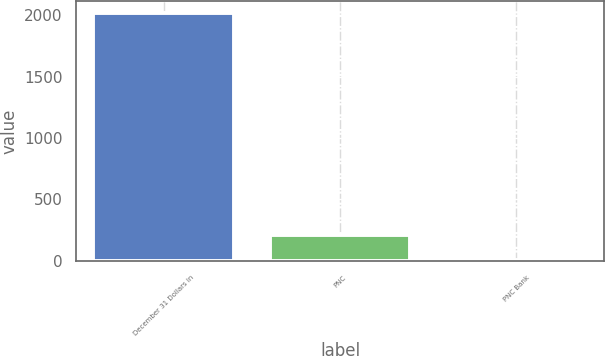Convert chart to OTSL. <chart><loc_0><loc_0><loc_500><loc_500><bar_chart><fcel>December 31 Dollars in<fcel>PNC<fcel>PNC Bank<nl><fcel>2015<fcel>210.86<fcel>10.4<nl></chart> 